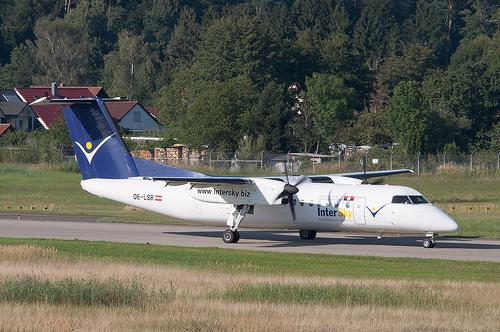Question: what color is the plane?
Choices:
A. Black and pink.
B. Red and yellow.
C. Blue and white.
D. Brown and teal.
Answer with the letter. Answer: C Question: where was the picture taken?
Choices:
A. On train tracks.
B. On the street.
C. On a bike trail.
D. On a runway.
Answer with the letter. Answer: D Question: what is under the plane?
Choices:
A. Pavement.
B. Concrete.
C. Runway.
D. Grass.
Answer with the letter. Answer: A 